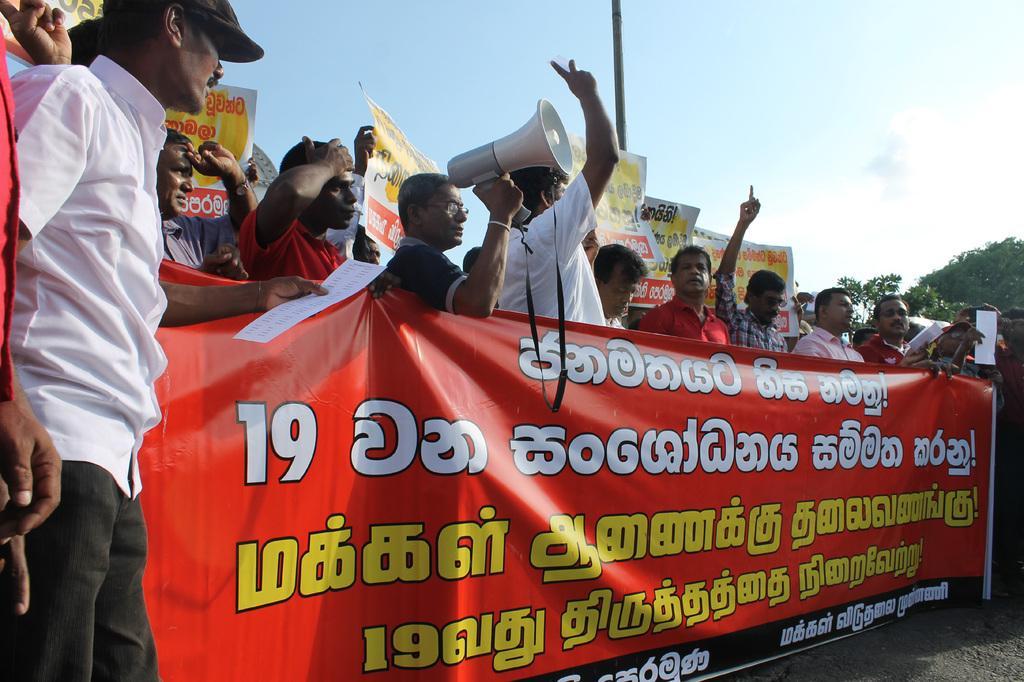Describe this image in one or two sentences. In this image I can see number of people are standing. Here I can see one of them is holding a megaphone and here I can see one is holding a paper. I can also see number of banners and on these banners I can see something is written. In background I can see few trees, a pole and the sky. 